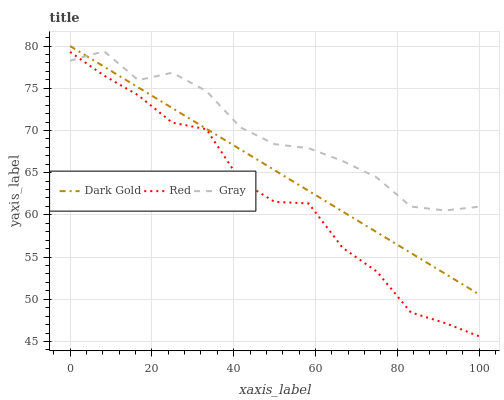Does Red have the minimum area under the curve?
Answer yes or no. Yes. Does Gray have the maximum area under the curve?
Answer yes or no. Yes. Does Dark Gold have the minimum area under the curve?
Answer yes or no. No. Does Dark Gold have the maximum area under the curve?
Answer yes or no. No. Is Dark Gold the smoothest?
Answer yes or no. Yes. Is Red the roughest?
Answer yes or no. Yes. Is Red the smoothest?
Answer yes or no. No. Is Dark Gold the roughest?
Answer yes or no. No. Does Red have the lowest value?
Answer yes or no. Yes. Does Dark Gold have the lowest value?
Answer yes or no. No. Does Dark Gold have the highest value?
Answer yes or no. Yes. Does Red have the highest value?
Answer yes or no. No. Is Red less than Dark Gold?
Answer yes or no. Yes. Is Dark Gold greater than Red?
Answer yes or no. Yes. Does Gray intersect Red?
Answer yes or no. Yes. Is Gray less than Red?
Answer yes or no. No. Is Gray greater than Red?
Answer yes or no. No. Does Red intersect Dark Gold?
Answer yes or no. No. 